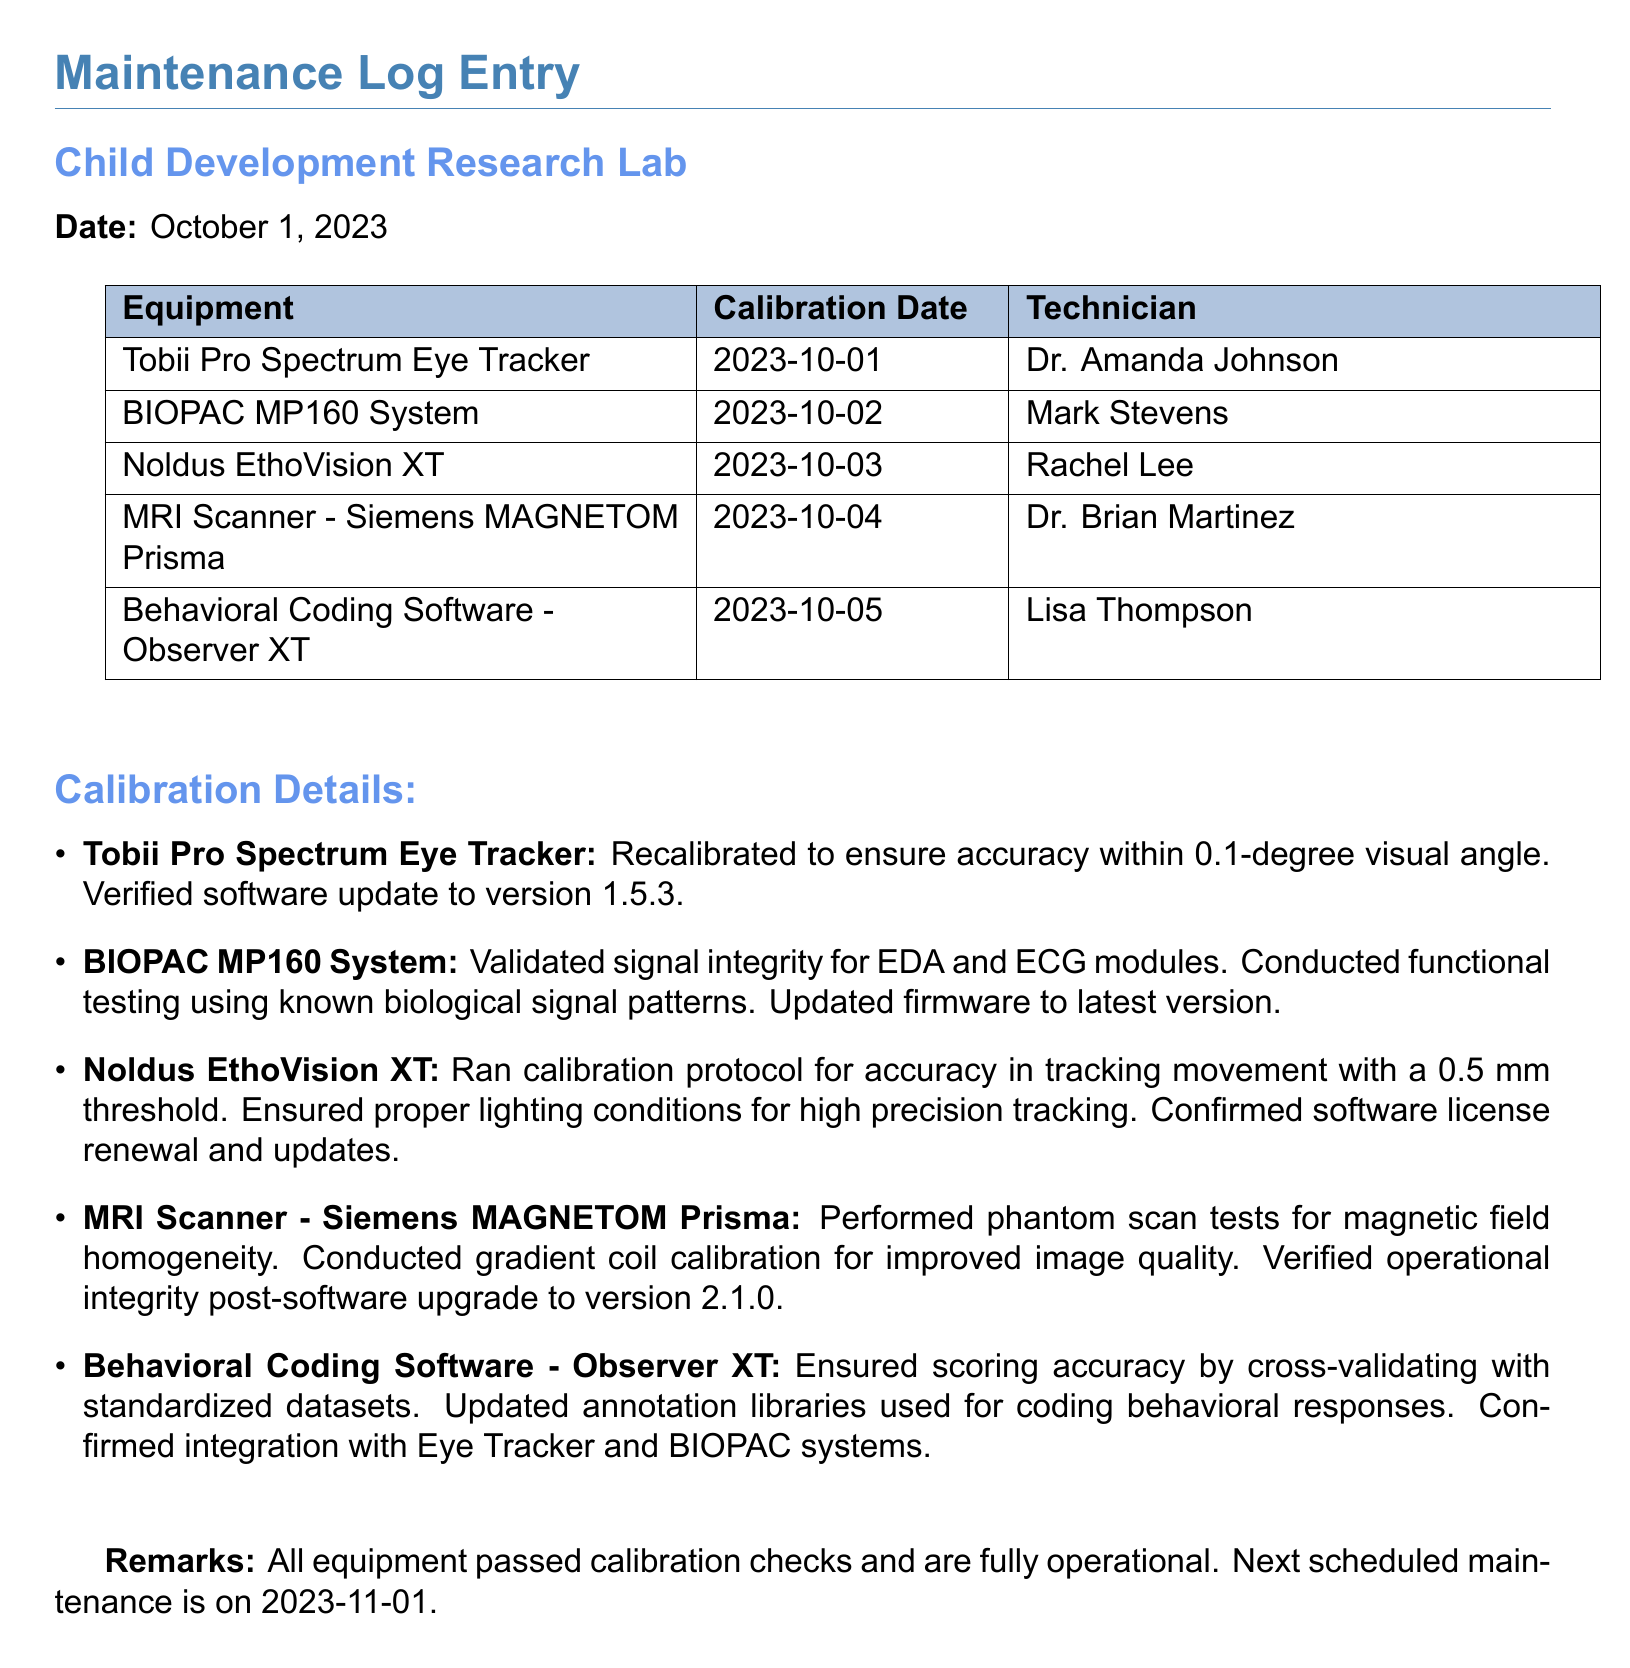What is the date of the maintenance log entry? The date of the maintenance log entry is specified at the top, which indicates the month and year of the entry.
Answer: October 1, 2023 Who calibrated the Tobii Pro Spectrum Eye Tracker? The technician involved in calibrating the Tobii Pro Spectrum Eye Tracker is listed in the table of equipment and their calibration details.
Answer: Dr. Amanda Johnson How many pieces of equipment were calibrated according to the log? By counting the items listed in the equipment section, we find the total number of calibrated pieces of equipment.
Answer: Five What was the calibration date for the MRI Scanner? The calibration date for the MRI Scanner is noted in the table beside the equipment name.
Answer: 2023-10-04 What is the next scheduled maintenance date? The next maintenance date is explicitly mentioned at the end of the log.
Answer: 2023-11-01 What software was updated for the BIOPAC MP160 System? The maintenance log specifies the firmware and any software updates performed during calibration.
Answer: Latest version What was the primary focus of the calibration for the Noldus EthoVision XT? The log mentions what the calibration for the Noldus EthoVision XT involved, highlighting the specific criteria used for accuracy.
Answer: Movement tracking accuracy How often is maintenance suggested based on this log? The log hints at a schedule by indicating the timing of the next maintenance after the current log entry.
Answer: Monthly 